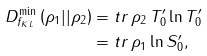<formula> <loc_0><loc_0><loc_500><loc_500>D _ { f _ { K L } } ^ { \min } \left ( \rho _ { 1 } | | \rho _ { 2 } \right ) & = t r \, \rho _ { 2 } \, T _ { 0 } ^ { \prime } \ln T _ { 0 } ^ { \prime } \\ & = t r \, \rho _ { 1 } \ln S _ { 0 } ^ { \prime } ,</formula> 